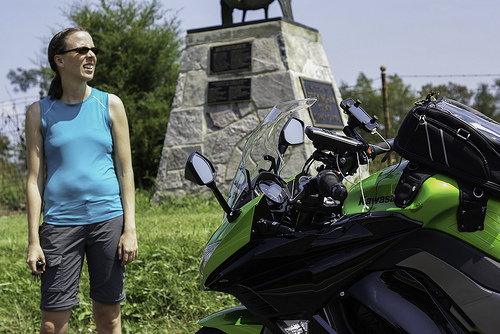<image>
Is there a woman on the motorcycle? No. The woman is not positioned on the motorcycle. They may be near each other, but the woman is not supported by or resting on top of the motorcycle. Is the bike on the bag? No. The bike is not positioned on the bag. They may be near each other, but the bike is not supported by or resting on top of the bag. 